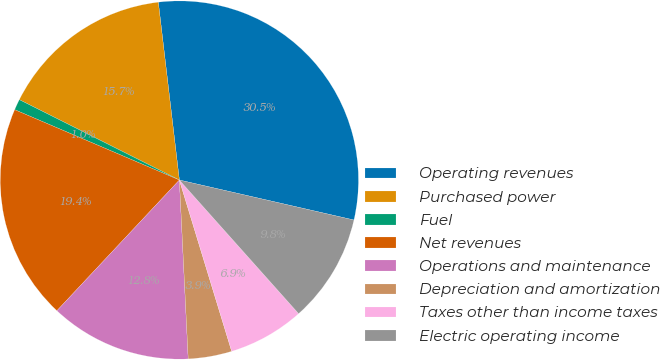Convert chart to OTSL. <chart><loc_0><loc_0><loc_500><loc_500><pie_chart><fcel>Operating revenues<fcel>Purchased power<fcel>Fuel<fcel>Net revenues<fcel>Operations and maintenance<fcel>Depreciation and amortization<fcel>Taxes other than income taxes<fcel>Electric operating income<nl><fcel>30.46%<fcel>15.72%<fcel>0.98%<fcel>19.44%<fcel>12.77%<fcel>3.93%<fcel>6.88%<fcel>9.82%<nl></chart> 